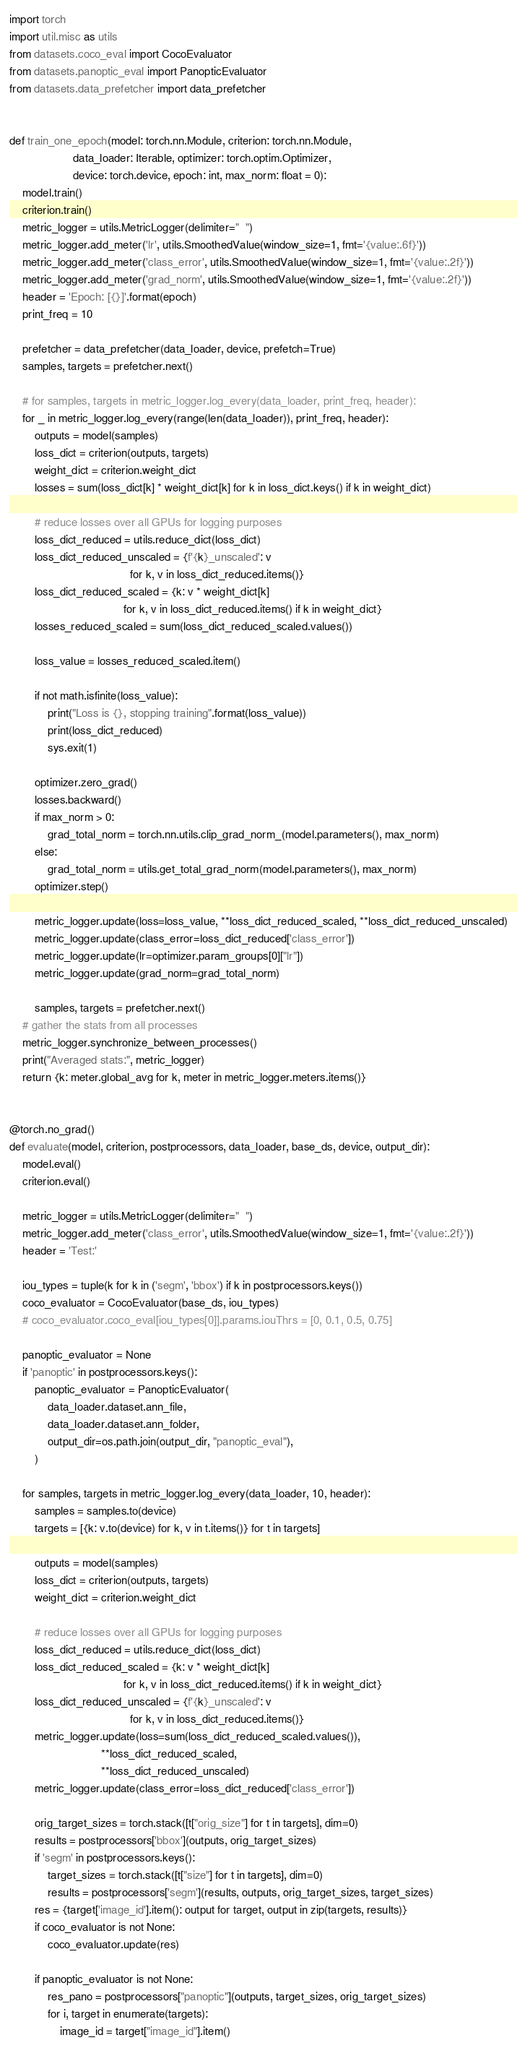Convert code to text. <code><loc_0><loc_0><loc_500><loc_500><_Python_>import torch
import util.misc as utils
from datasets.coco_eval import CocoEvaluator
from datasets.panoptic_eval import PanopticEvaluator
from datasets.data_prefetcher import data_prefetcher


def train_one_epoch(model: torch.nn.Module, criterion: torch.nn.Module,
                    data_loader: Iterable, optimizer: torch.optim.Optimizer,
                    device: torch.device, epoch: int, max_norm: float = 0):
    model.train()
    criterion.train()
    metric_logger = utils.MetricLogger(delimiter="  ")
    metric_logger.add_meter('lr', utils.SmoothedValue(window_size=1, fmt='{value:.6f}'))
    metric_logger.add_meter('class_error', utils.SmoothedValue(window_size=1, fmt='{value:.2f}'))
    metric_logger.add_meter('grad_norm', utils.SmoothedValue(window_size=1, fmt='{value:.2f}'))
    header = 'Epoch: [{}]'.format(epoch)
    print_freq = 10

    prefetcher = data_prefetcher(data_loader, device, prefetch=True)
    samples, targets = prefetcher.next()

    # for samples, targets in metric_logger.log_every(data_loader, print_freq, header):
    for _ in metric_logger.log_every(range(len(data_loader)), print_freq, header):
        outputs = model(samples)
        loss_dict = criterion(outputs, targets)
        weight_dict = criterion.weight_dict
        losses = sum(loss_dict[k] * weight_dict[k] for k in loss_dict.keys() if k in weight_dict)

        # reduce losses over all GPUs for logging purposes
        loss_dict_reduced = utils.reduce_dict(loss_dict)
        loss_dict_reduced_unscaled = {f'{k}_unscaled': v
                                      for k, v in loss_dict_reduced.items()}
        loss_dict_reduced_scaled = {k: v * weight_dict[k]
                                    for k, v in loss_dict_reduced.items() if k in weight_dict}
        losses_reduced_scaled = sum(loss_dict_reduced_scaled.values())

        loss_value = losses_reduced_scaled.item()

        if not math.isfinite(loss_value):
            print("Loss is {}, stopping training".format(loss_value))
            print(loss_dict_reduced)
            sys.exit(1)

        optimizer.zero_grad()
        losses.backward()
        if max_norm > 0:
            grad_total_norm = torch.nn.utils.clip_grad_norm_(model.parameters(), max_norm)
        else:
            grad_total_norm = utils.get_total_grad_norm(model.parameters(), max_norm)
        optimizer.step()

        metric_logger.update(loss=loss_value, **loss_dict_reduced_scaled, **loss_dict_reduced_unscaled)
        metric_logger.update(class_error=loss_dict_reduced['class_error'])
        metric_logger.update(lr=optimizer.param_groups[0]["lr"])
        metric_logger.update(grad_norm=grad_total_norm)

        samples, targets = prefetcher.next()
    # gather the stats from all processes
    metric_logger.synchronize_between_processes()
    print("Averaged stats:", metric_logger)
    return {k: meter.global_avg for k, meter in metric_logger.meters.items()}


@torch.no_grad()
def evaluate(model, criterion, postprocessors, data_loader, base_ds, device, output_dir):
    model.eval()
    criterion.eval()

    metric_logger = utils.MetricLogger(delimiter="  ")
    metric_logger.add_meter('class_error', utils.SmoothedValue(window_size=1, fmt='{value:.2f}'))
    header = 'Test:'

    iou_types = tuple(k for k in ('segm', 'bbox') if k in postprocessors.keys())
    coco_evaluator = CocoEvaluator(base_ds, iou_types)
    # coco_evaluator.coco_eval[iou_types[0]].params.iouThrs = [0, 0.1, 0.5, 0.75]

    panoptic_evaluator = None
    if 'panoptic' in postprocessors.keys():
        panoptic_evaluator = PanopticEvaluator(
            data_loader.dataset.ann_file,
            data_loader.dataset.ann_folder,
            output_dir=os.path.join(output_dir, "panoptic_eval"),
        )

    for samples, targets in metric_logger.log_every(data_loader, 10, header):
        samples = samples.to(device)
        targets = [{k: v.to(device) for k, v in t.items()} for t in targets]

        outputs = model(samples)
        loss_dict = criterion(outputs, targets)
        weight_dict = criterion.weight_dict

        # reduce losses over all GPUs for logging purposes
        loss_dict_reduced = utils.reduce_dict(loss_dict)
        loss_dict_reduced_scaled = {k: v * weight_dict[k]
                                    for k, v in loss_dict_reduced.items() if k in weight_dict}
        loss_dict_reduced_unscaled = {f'{k}_unscaled': v
                                      for k, v in loss_dict_reduced.items()}
        metric_logger.update(loss=sum(loss_dict_reduced_scaled.values()),
                             **loss_dict_reduced_scaled,
                             **loss_dict_reduced_unscaled)
        metric_logger.update(class_error=loss_dict_reduced['class_error'])

        orig_target_sizes = torch.stack([t["orig_size"] for t in targets], dim=0)
        results = postprocessors['bbox'](outputs, orig_target_sizes)
        if 'segm' in postprocessors.keys():
            target_sizes = torch.stack([t["size"] for t in targets], dim=0)
            results = postprocessors['segm'](results, outputs, orig_target_sizes, target_sizes)
        res = {target['image_id'].item(): output for target, output in zip(targets, results)}
        if coco_evaluator is not None:
            coco_evaluator.update(res)

        if panoptic_evaluator is not None:
            res_pano = postprocessors["panoptic"](outputs, target_sizes, orig_target_sizes)
            for i, target in enumerate(targets):
                image_id = target["image_id"].item()</code> 